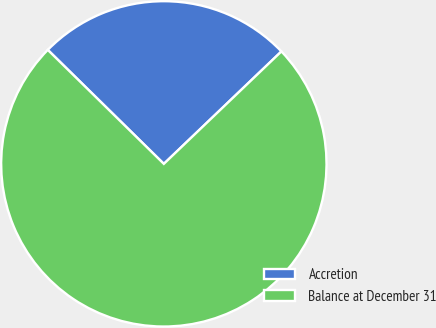Convert chart to OTSL. <chart><loc_0><loc_0><loc_500><loc_500><pie_chart><fcel>Accretion<fcel>Balance at December 31<nl><fcel>25.5%<fcel>74.5%<nl></chart> 